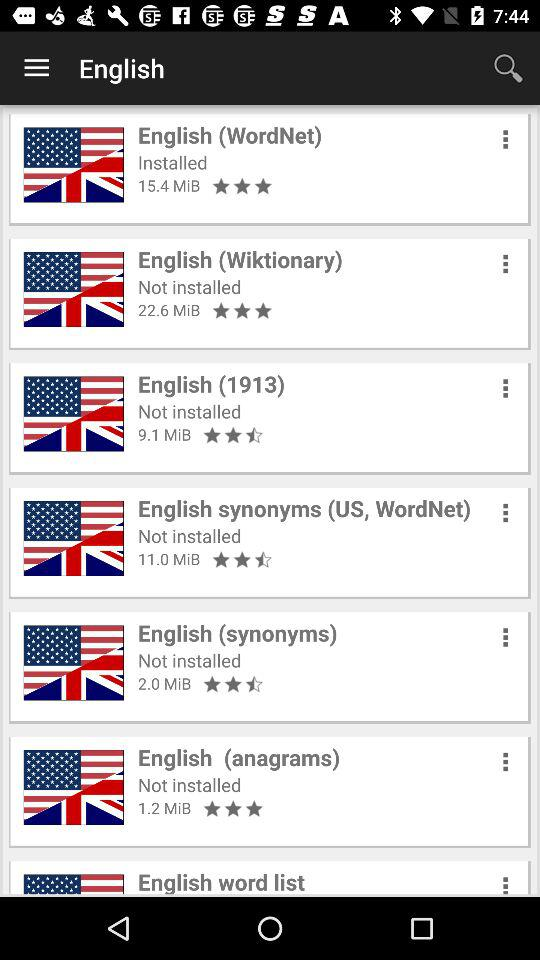What is the rating of the "English (WordNet)" app? The rating of the app is 3 stars. 